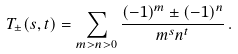Convert formula to latex. <formula><loc_0><loc_0><loc_500><loc_500>T _ { \pm } ( s , t ) = \sum _ { m > n > 0 } \frac { ( - 1 ) ^ { m } \pm ( - 1 ) ^ { n } } { m ^ { s } n ^ { t } } \, .</formula> 